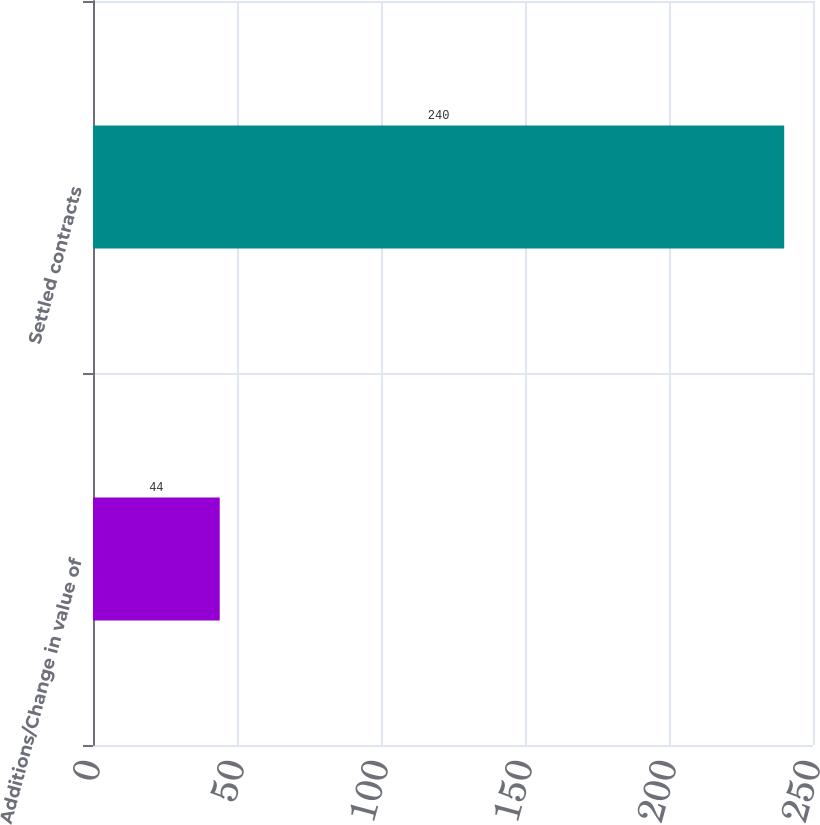Convert chart. <chart><loc_0><loc_0><loc_500><loc_500><bar_chart><fcel>Additions/Change in value of<fcel>Settled contracts<nl><fcel>44<fcel>240<nl></chart> 